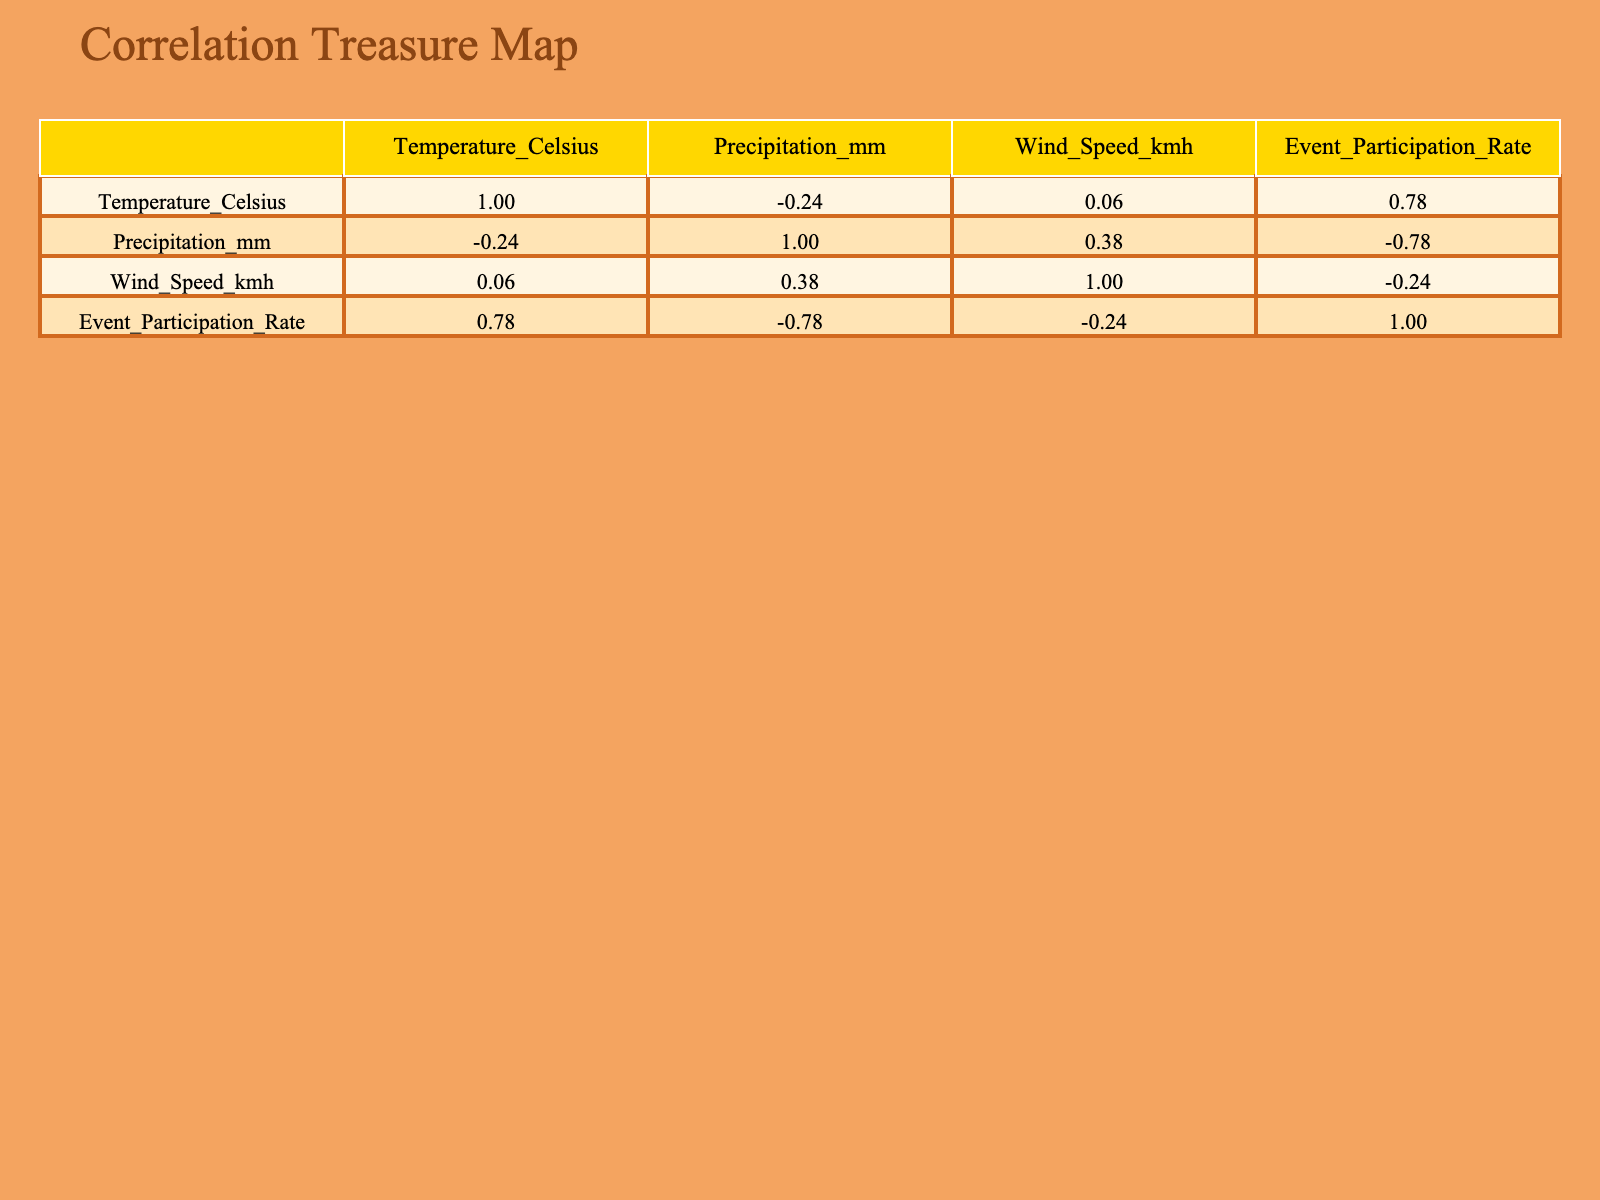What is the participation rate for sunny weather? The table shows that under sunny weather conditions, the event participation rate is explicitly listed as 85.
Answer: 85 Which weather condition has the lowest participation rate? By examining the table, the lowest participation rate appears next to stormy weather, which is listed as 10.
Answer: 10 What is the average temperature when participation rate exceeds 60? To find the average temperature for weather conditions with a participation rate above 60, we look at the relevant entries: Sunny (28), Partly Cloudy (25), Cloudy (22), and Mild (24). The average can be calculated as (28 + 25 + 22 + 24) / 4 = 24.75.
Answer: 24.75 True or False: Windy weather has a higher participation rate than rainy weather. The participation rate for windy weather is 50, while for rainy weather, it is 30. Since 50 is greater than 30, the statement is true.
Answer: True What is the correlation between temperature and event participation rate? Looking at the correlation matrix, we see the correlation value between temperature and event participation rate is likely to be positive, suggesting that higher temperatures are associated with higher participation rates. A specific value can be read directly from the table.
Answer: Positive correlation What is the total precipitation for weather conditions with participation below 50? Examining the table, we find rainy (15mm) and stormy (25mm) conditions have participation rates below 50. The total precipitation from these two entries is 15 + 25 = 40mm.
Answer: 40mm How does the participation rate change when precipitation is 0? The table shows three weather conditions with 0 precipitation: Sunny (85), Partly Cloudy (75), and Windy (50). The participation rates are all above 50, indicating that zero precipitation tends to correlate with higher participation rates.
Answer: Higher participation rates What is the difference in participation rates between cloudy and snowy weather? The participation rate for cloudy weather is 60, while for snowy weather, it is 5. Thus, the difference is 60 - 5 = 55.
Answer: 55 True or False: A higher wind speed is associated with higher participation rates. By reviewing the data, we can compare the wind speeds and respective participation rates. For example, stormy weather has a wind speed of 30km/h and a rate of 10, whereas windy conditions have a wind speed of 40km/h and a rate of 50. This shows that higher wind speeds can correspond to both lower and higher participation rates, indicating the statement is false.
Answer: False 